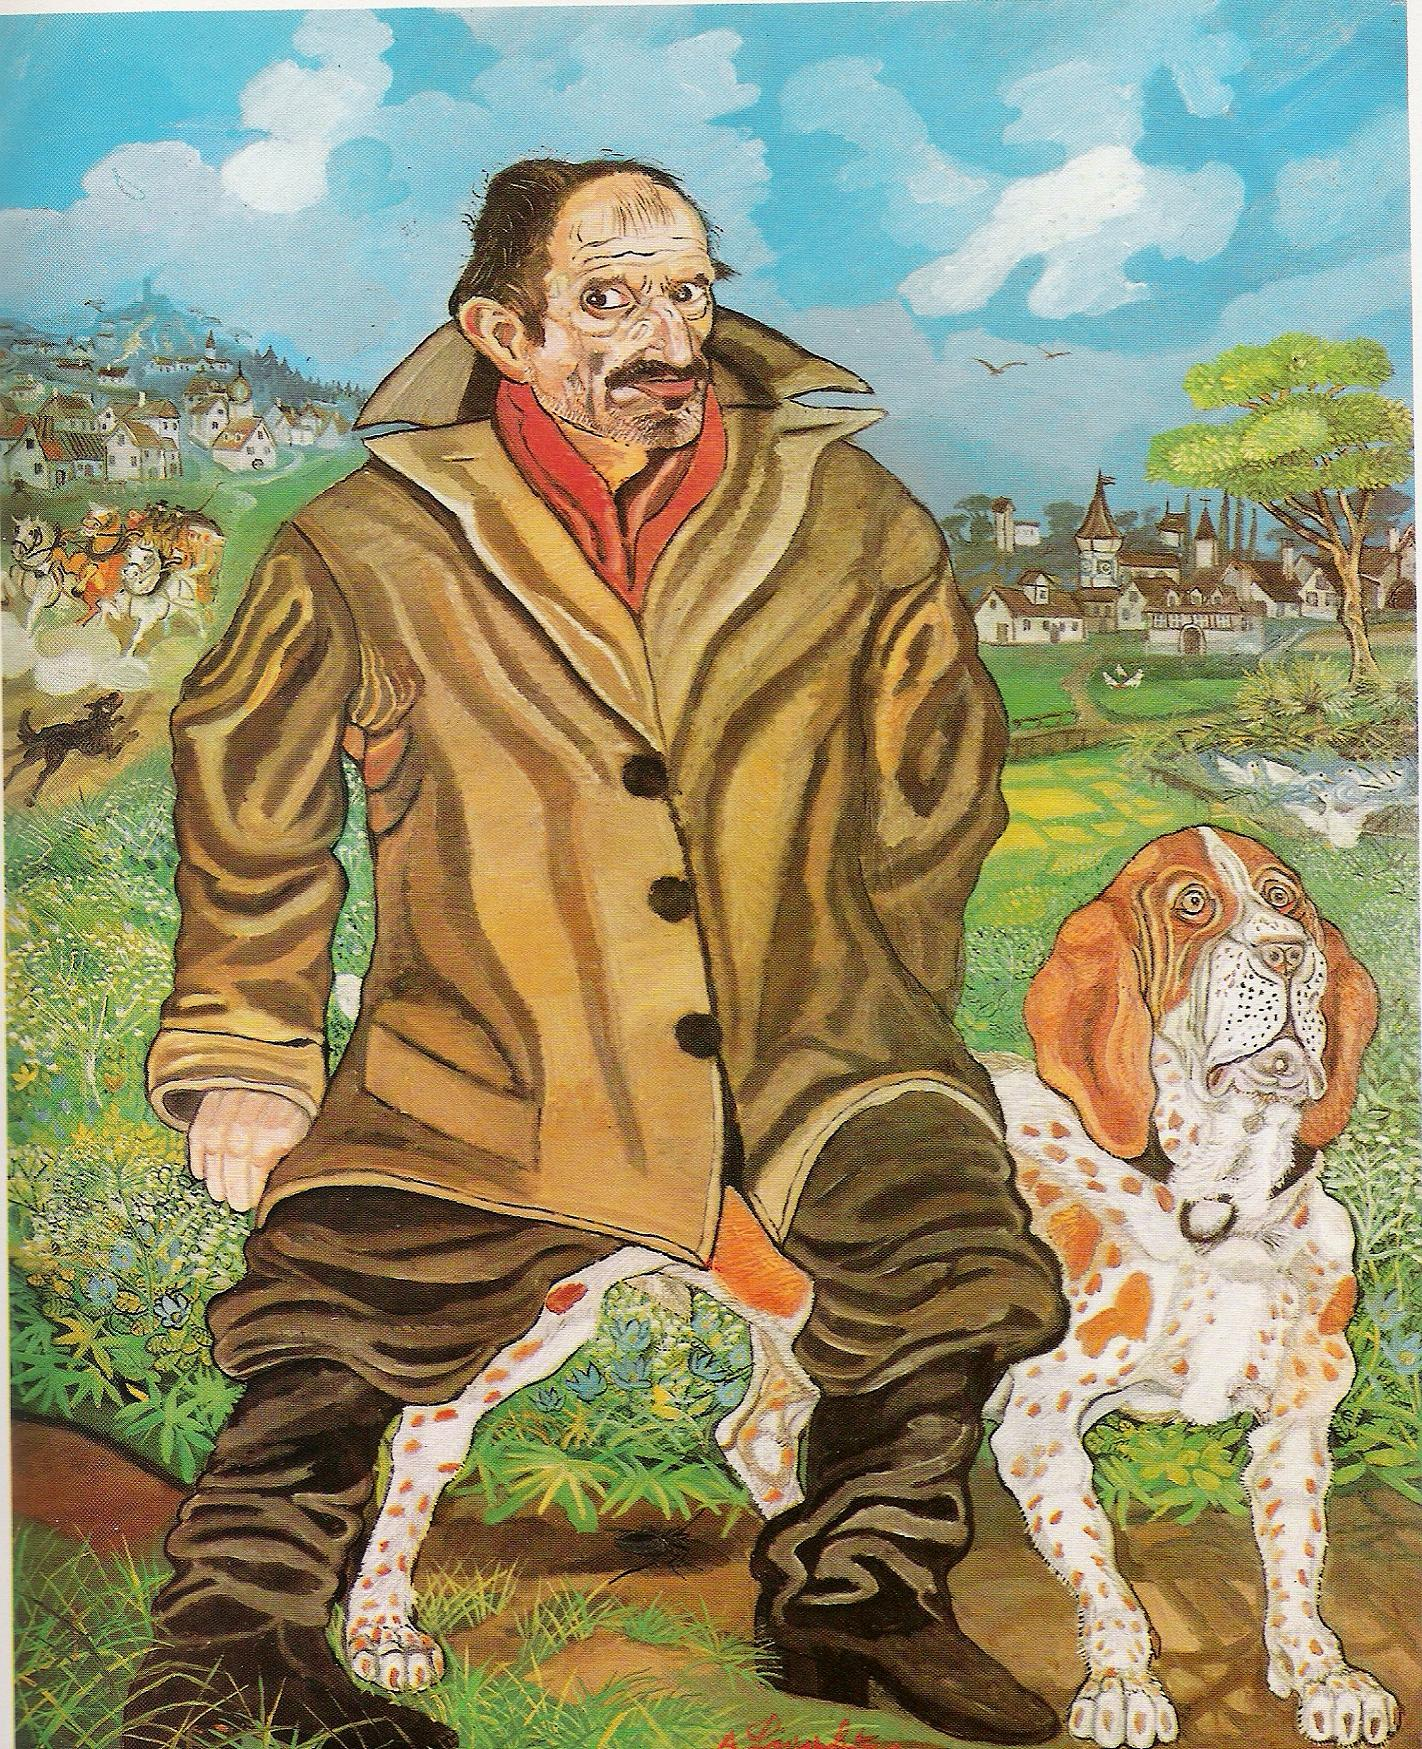What do you think the man and his dog might be experiencing in this surreal landscape? In this surreal landscape, the man and his dog could be embarking on a journey through a world that transcends everyday reality. They might be adventurers or travelers exploring new and mystical lands, each turn revealing a new marvel or a hidden challenge. The man's thoughtful and experienced look suggests he has embarked on many such journeys, while the dog, with its attentive expression, appears to be his loyal and brave companion. Together, they may be experiencing the beauty of the natural world, the mystery of ancient civilizations, or even the enchantments of magical realms depicted in the vivid surroundings. Why does this scene feel so captivating? This scene captures the imagination due to its masterful contrast of realism and fantasy. The man's detailed expression and the lifelike portrayal of the dog ground the viewer in reality, while the fantastical and vibrant backdrop invites dreams and limitless possibilities. The combination of familiar elements—such as the village and the castle—with an artistic style that defies conventional logic captures the viewer's attention and curiosity. Additionally, the bright and varied palette of colors injects energy and awe, making the whole composition not just a visual, but an emotional and imaginative experience. If you could step into this scene, what would you do first? If stepping into this enchanting scene, the first inclination might be to explore the charming village. Wandering through the narrow, winding streets, meeting the local inhabitants, and perhaps listening to their tales and legends would be fascinating. Each building and corner might hold a story, a secret passage, or a glimpse into the village’s rich history. Strolling down to the river for a serene moment, observing the reflections of the village in the rippling water, would add to the sense of wonderment. The culmination of this exploration would be a trek up to the castle, where the wider landscape could be admired in its full, surreal glory, perhaps unlocking deeper mysteries of this magical world. 